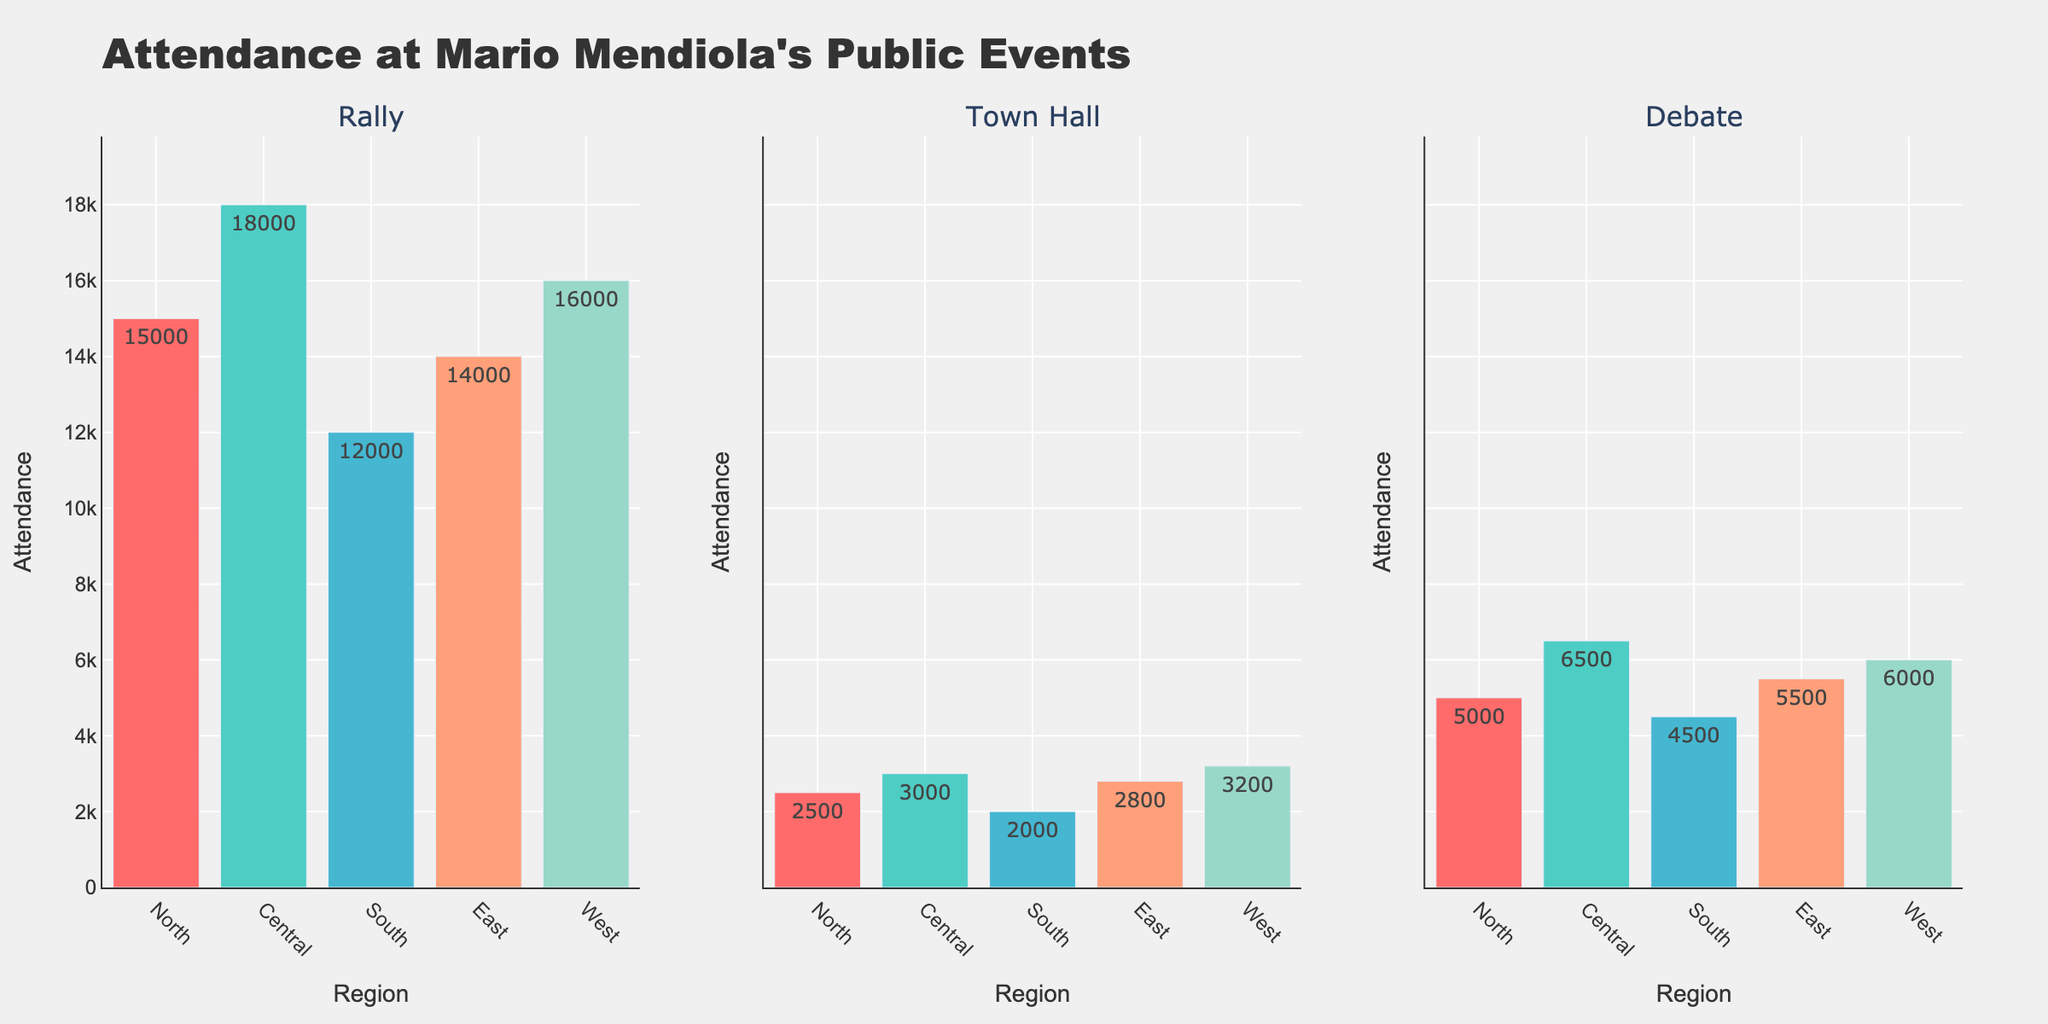What is the title of the figure? The title of the figure is located at the top of the chart and it reads "Attendance at Mario Mendiola's Public Events".
Answer: Attendance at Mario Mendiola's Public Events Which region had the highest attendance for Rallies? The highest attendance for Rallies can be identified by looking at the tallest bar in the Rally subplot. The Central region has the highest attendance at 18,000.
Answer: Central How does attendance at Town Halls compare between the North and the South regions? To compare the attendance, look at the height of the bars for Town Halls in the North and South regions. The North region has 2,500 attendees, and the South region has 2,000 attendees.
Answer: North > South What is the average attendance for Debates across all regions? Add the attendance numbers for Debates across all regions (5,000 + 6,500 + 4,500 + 5,500 + 6,000 = 27,500) and then divide by the number of regions (5). The average attendance is 27,500 / 5 = 5,500.
Answer: 5,500 Which event type had the highest total attendance across all regions? Calculate the total attendance for each event type: Rallies (15,000 + 18,000 + 12,000 + 14,000 + 16,000 = 75,000), Town Halls (2,500 + 3,000 + 2,000 + 2,800 + 3,200 = 13,500), and Debates (5,000 + 6,500 + 4,500 + 5,500 + 6,000 = 27,500). Rallies have the highest total attendance.
Answer: Rallies In which region does the attendance for Town Halls surpass the attendance for Debates? Compare the attendance for Town Halls and Debates in each region. Only in the West region, the Town Hall attendance (3,200) surpasses the Debate attendance (6,000).
Answer: None How many regions have a Rally attendance greater than 15,000? Identify the regions where the Rally attendance is greater than 15,000 by looking at the Rally subplot. The Central, East, and West regions have Rally attendance greater than 15,000.
Answer: 3 What is the difference in attendance between the highest and lowest attended Town Hall events? Identify the highest (West with 3,200) and lowest (South with 2,000) attended Town Hall events. The difference is 3,200 - 2,000 = 1,200.
Answer: 1,200 